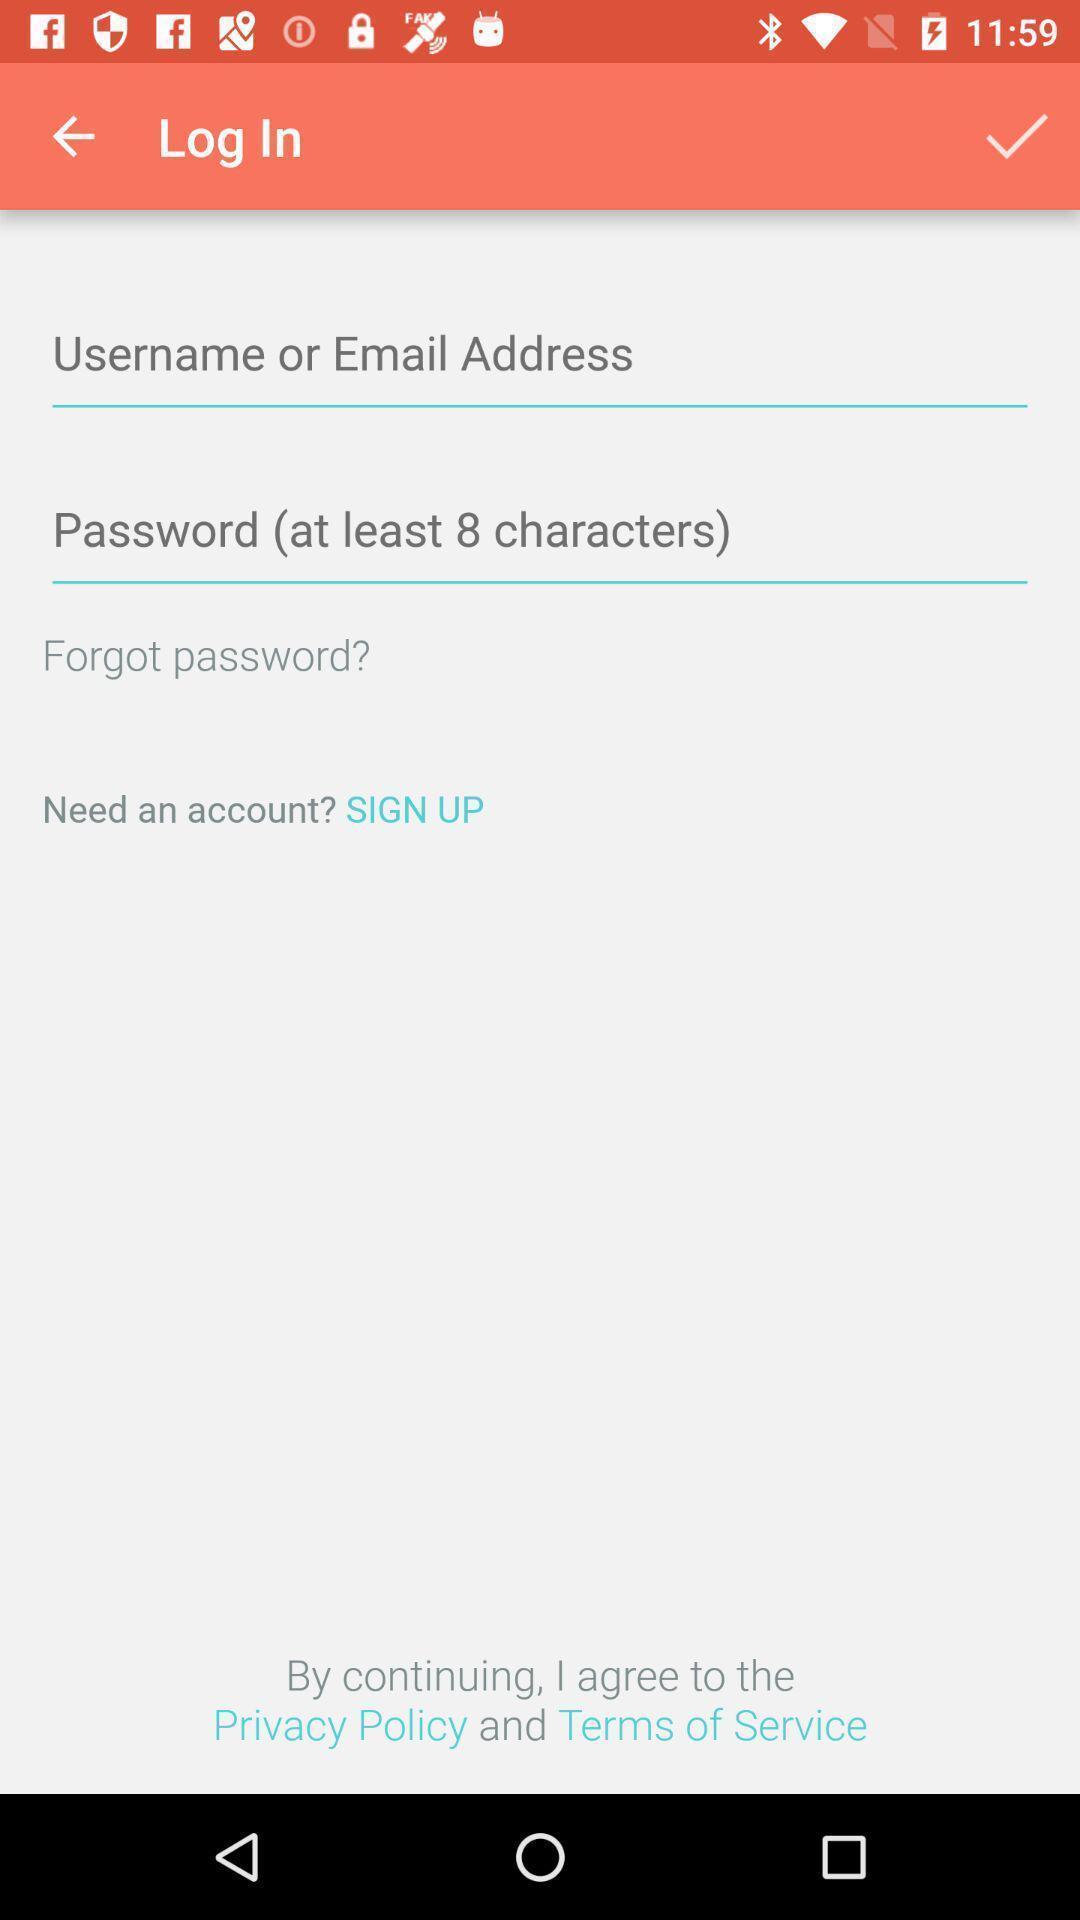Provide a textual representation of this image. Page displaying to enter details. 